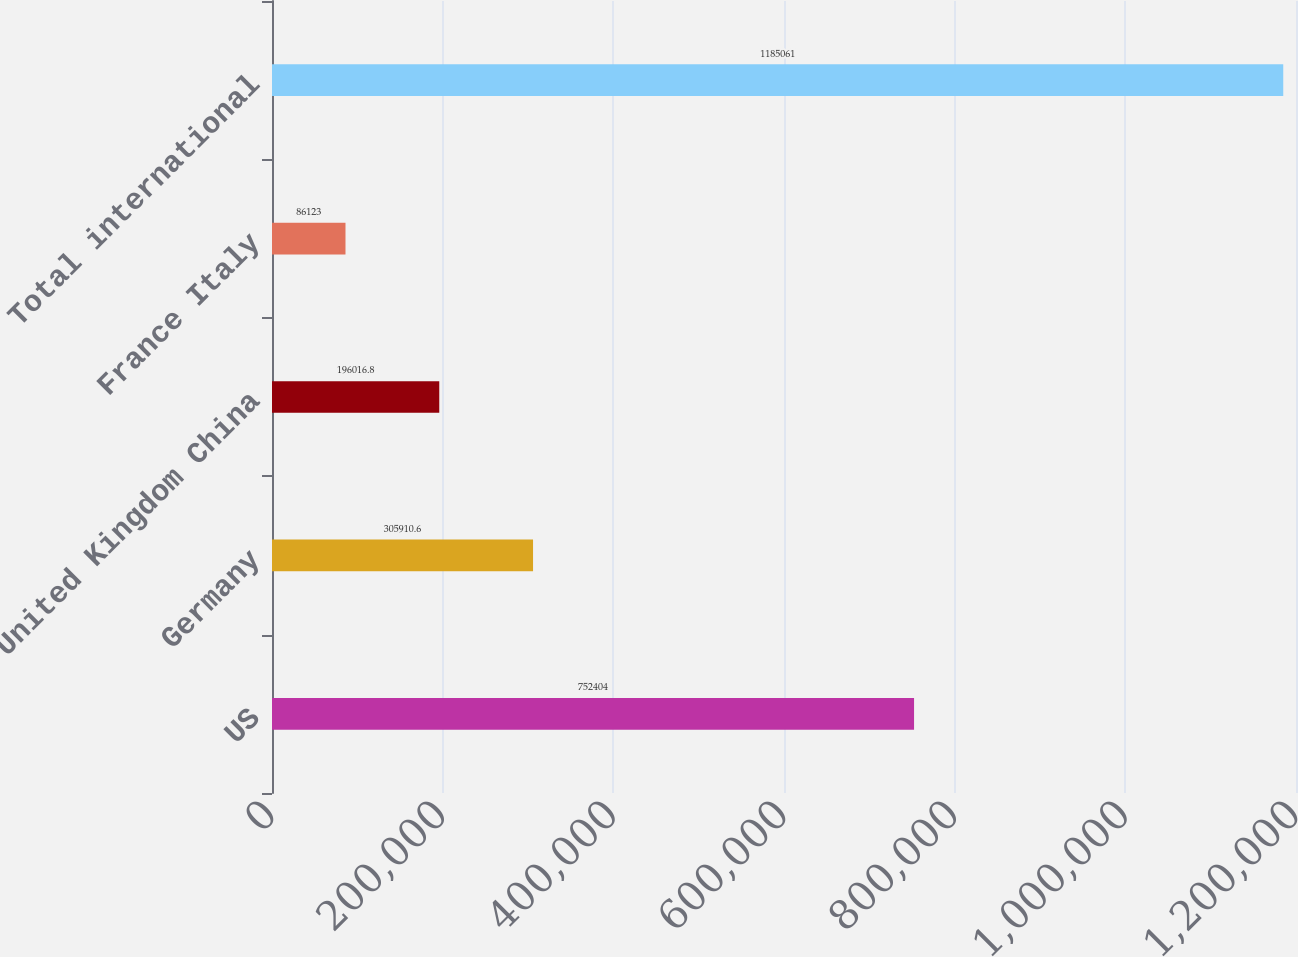<chart> <loc_0><loc_0><loc_500><loc_500><bar_chart><fcel>US<fcel>Germany<fcel>United Kingdom China<fcel>France Italy<fcel>Total international<nl><fcel>752404<fcel>305911<fcel>196017<fcel>86123<fcel>1.18506e+06<nl></chart> 